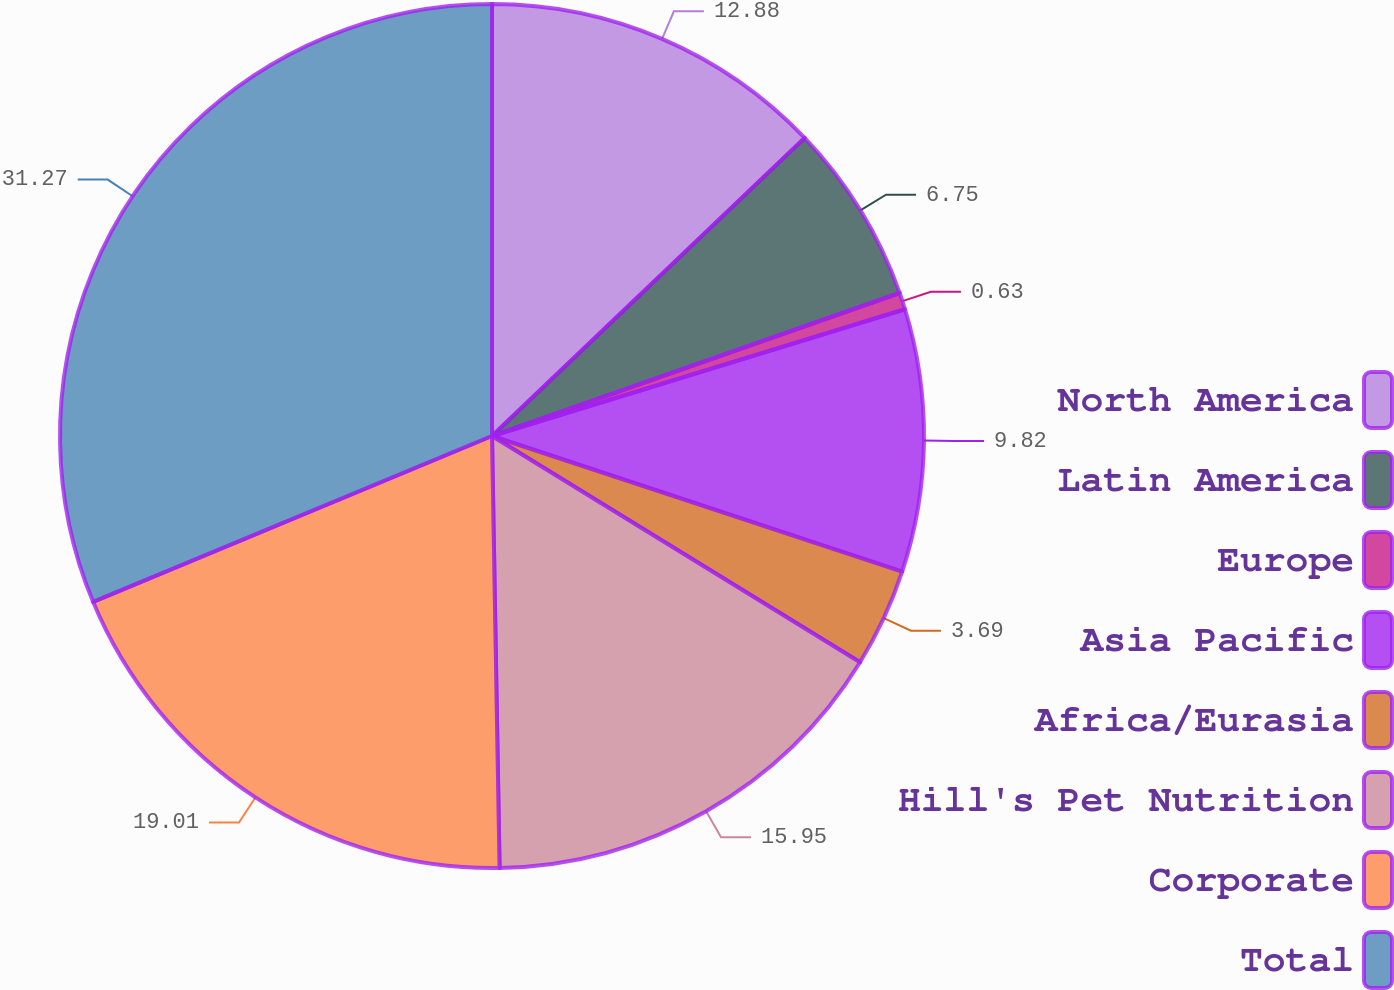Convert chart to OTSL. <chart><loc_0><loc_0><loc_500><loc_500><pie_chart><fcel>North America<fcel>Latin America<fcel>Europe<fcel>Asia Pacific<fcel>Africa/Eurasia<fcel>Hill's Pet Nutrition<fcel>Corporate<fcel>Total<nl><fcel>12.88%<fcel>6.75%<fcel>0.63%<fcel>9.82%<fcel>3.69%<fcel>15.95%<fcel>19.01%<fcel>31.27%<nl></chart> 